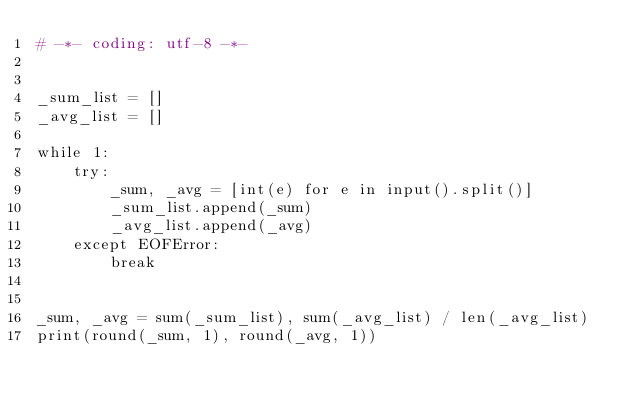<code> <loc_0><loc_0><loc_500><loc_500><_Python_># -*- coding: utf-8 -*-


_sum_list = []
_avg_list = []

while 1:
    try:
        _sum, _avg = [int(e) for e in input().split()]
        _sum_list.append(_sum)
        _avg_list.append(_avg)
    except EOFError:
        break


_sum, _avg = sum(_sum_list), sum(_avg_list) / len(_avg_list)
print(round(_sum, 1), round(_avg, 1))</code> 